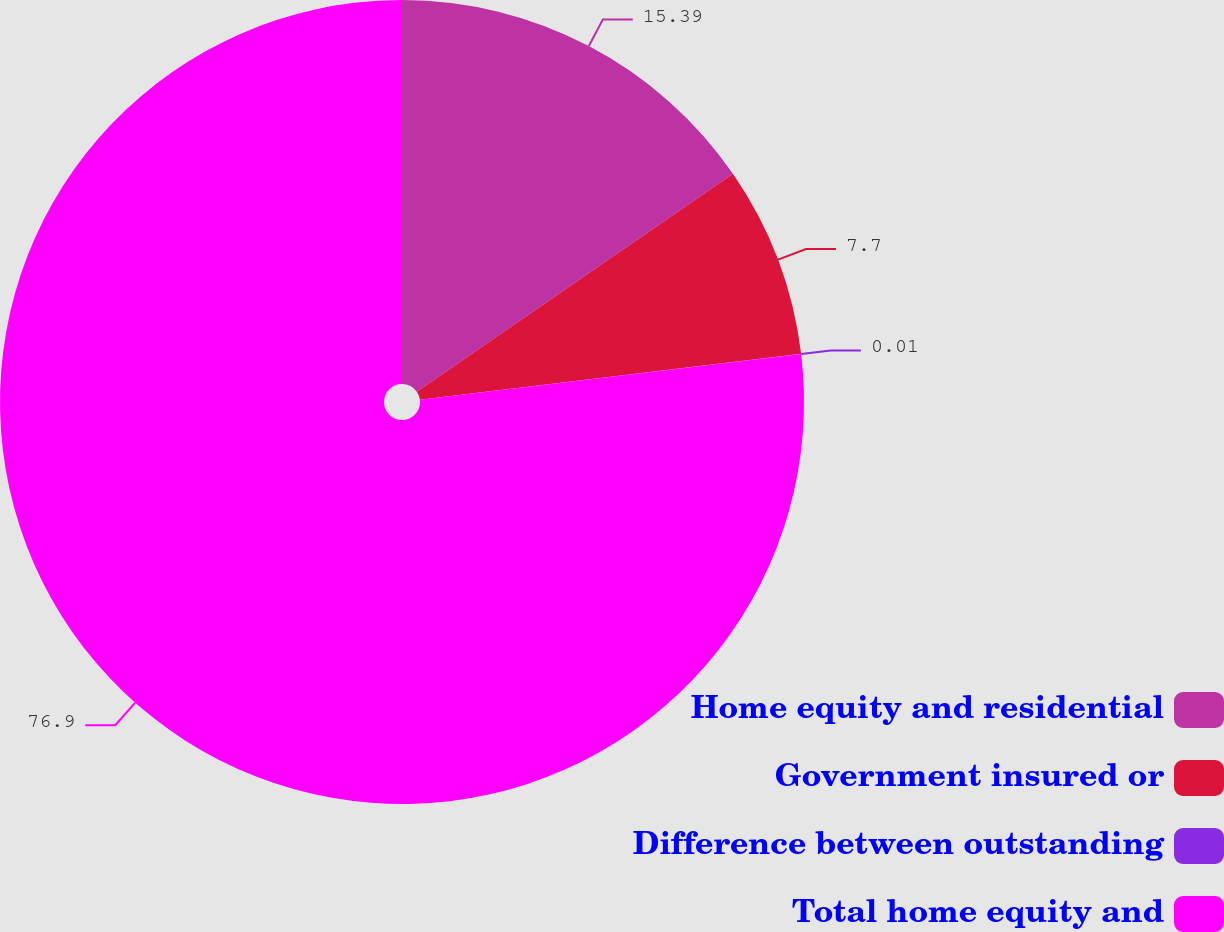Convert chart to OTSL. <chart><loc_0><loc_0><loc_500><loc_500><pie_chart><fcel>Home equity and residential<fcel>Government insured or<fcel>Difference between outstanding<fcel>Total home equity and<nl><fcel>15.39%<fcel>7.7%<fcel>0.01%<fcel>76.9%<nl></chart> 